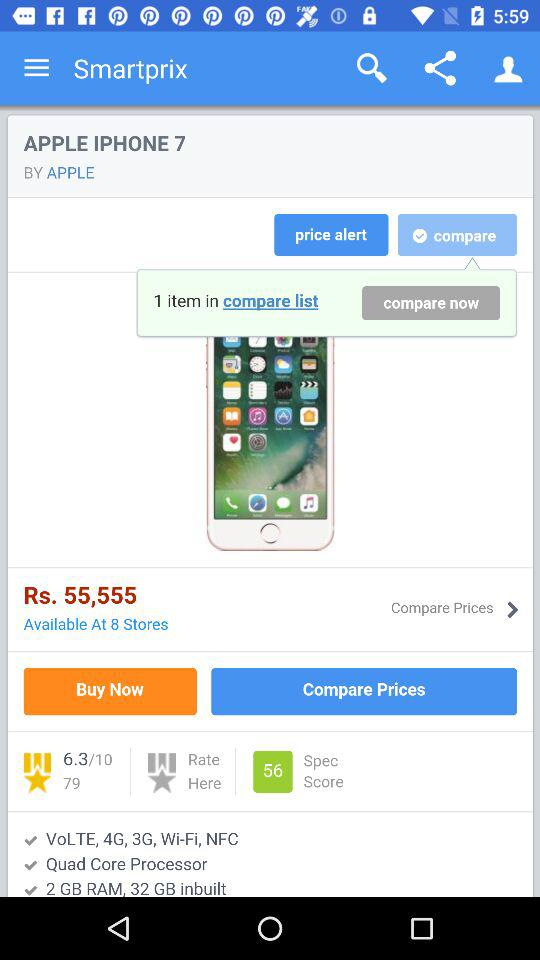What is the total number of items in the compare list? There is only one item in the compare list. 